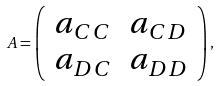<formula> <loc_0><loc_0><loc_500><loc_500>A = \left ( \begin{array} { c c } a _ { C C } & a _ { C D } \\ a _ { D C } & a _ { D D } \end{array} \right ) ,</formula> 